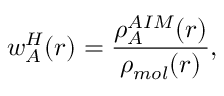<formula> <loc_0><loc_0><loc_500><loc_500>w _ { A } ^ { H } ( r ) = \frac { \rho _ { A } ^ { A I M } ( r ) } { \rho _ { m o l } ( r ) } ,</formula> 